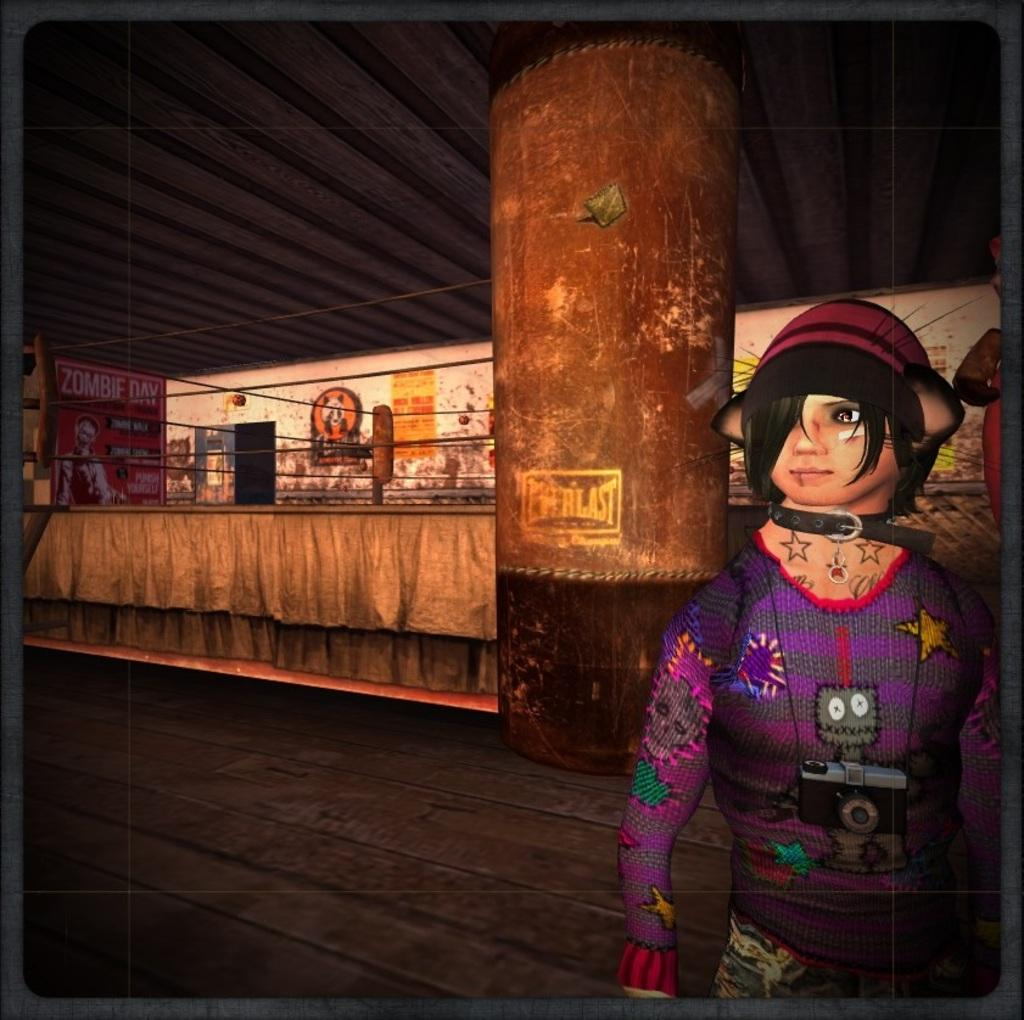What type of picture is in the image? The image contains an animated picture. Can you describe the person in the image? There is a person wearing a purple dress in the image. What can be seen in the background of the image? There is a pillar and objects attached to the wall in the background of the image. What type of spot or patch can be seen on the person's dress in the image? There is no mention of a spot or patch on the person's dress in the image. How does the person's hearing affect their interaction with the animated picture in the image? There is no information about the person's hearing in the image, so it cannot be determined how it might affect their interaction with the animated picture. 